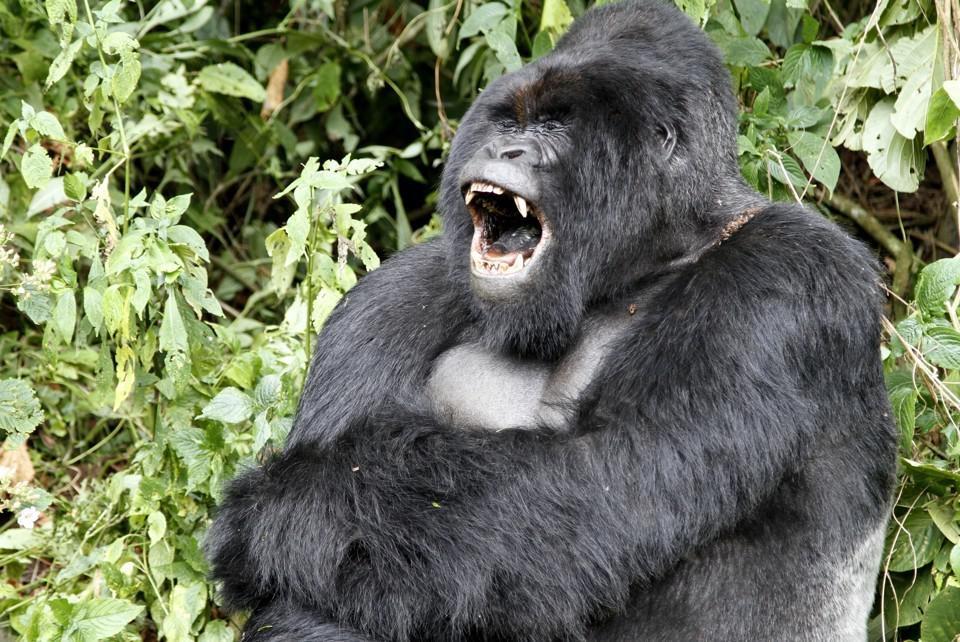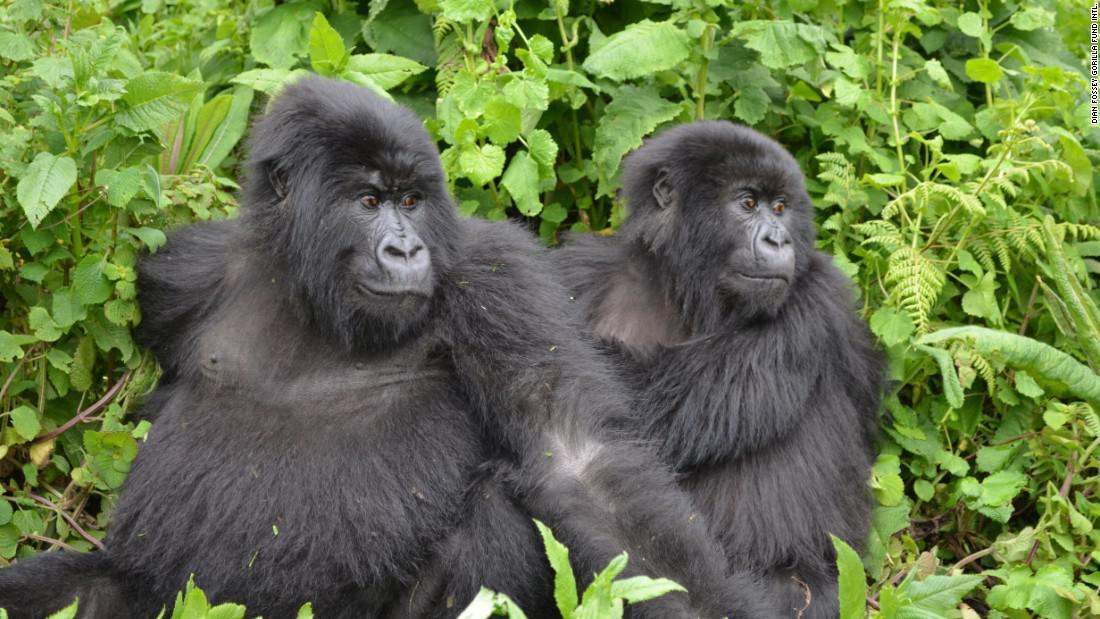The first image is the image on the left, the second image is the image on the right. Analyze the images presented: Is the assertion "There are more than three apes visible, whether in foreground or background." valid? Answer yes or no. No. The first image is the image on the left, the second image is the image on the right. Given the left and right images, does the statement "There are exactly three gorillas in the pair of images." hold true? Answer yes or no. Yes. 